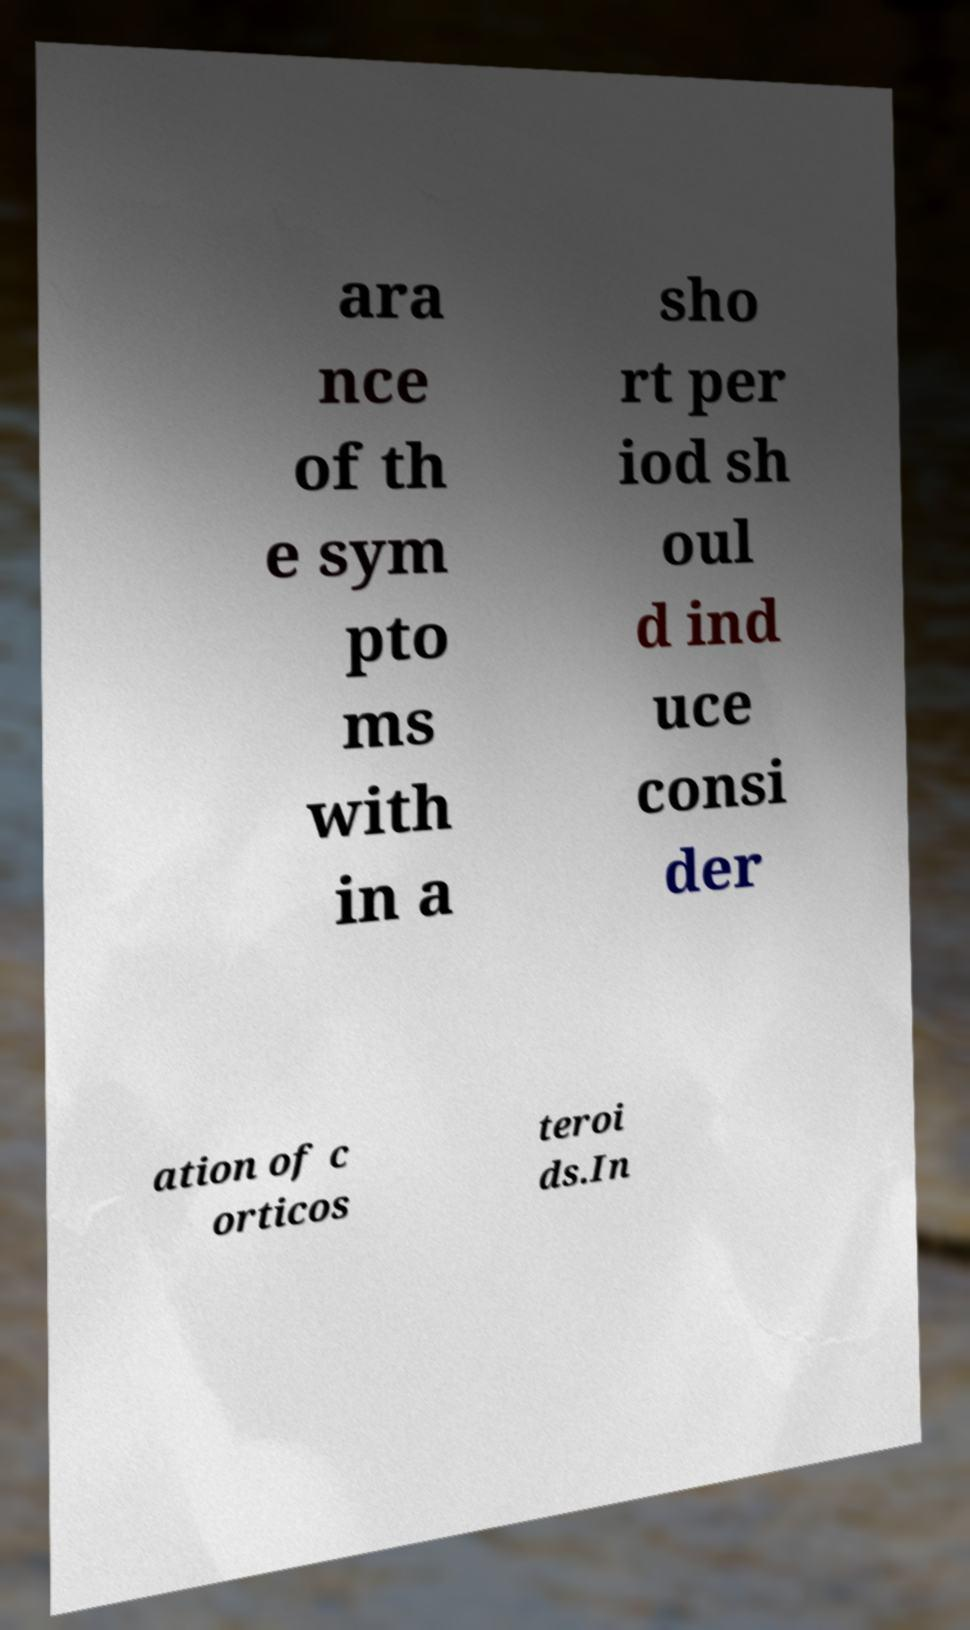There's text embedded in this image that I need extracted. Can you transcribe it verbatim? ara nce of th e sym pto ms with in a sho rt per iod sh oul d ind uce consi der ation of c orticos teroi ds.In 